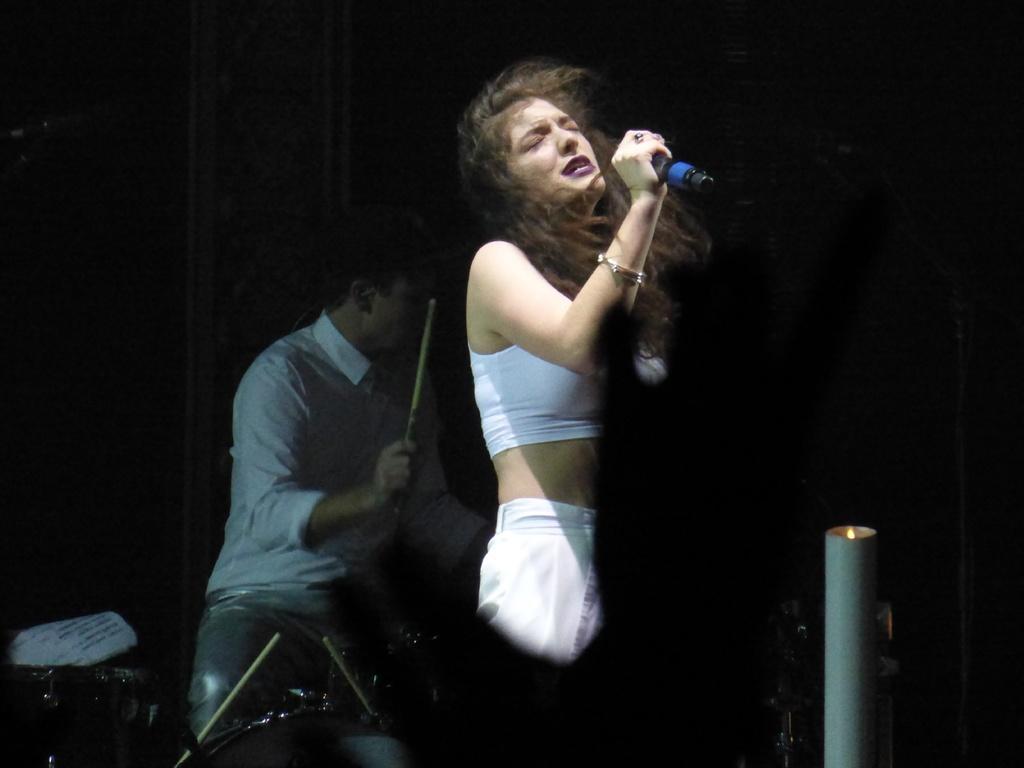Describe this image in one or two sentences. In this picture we can see a woman who is holding a mike with her hand. She is singing. Here we can see a man who is playing some musical instruments. 